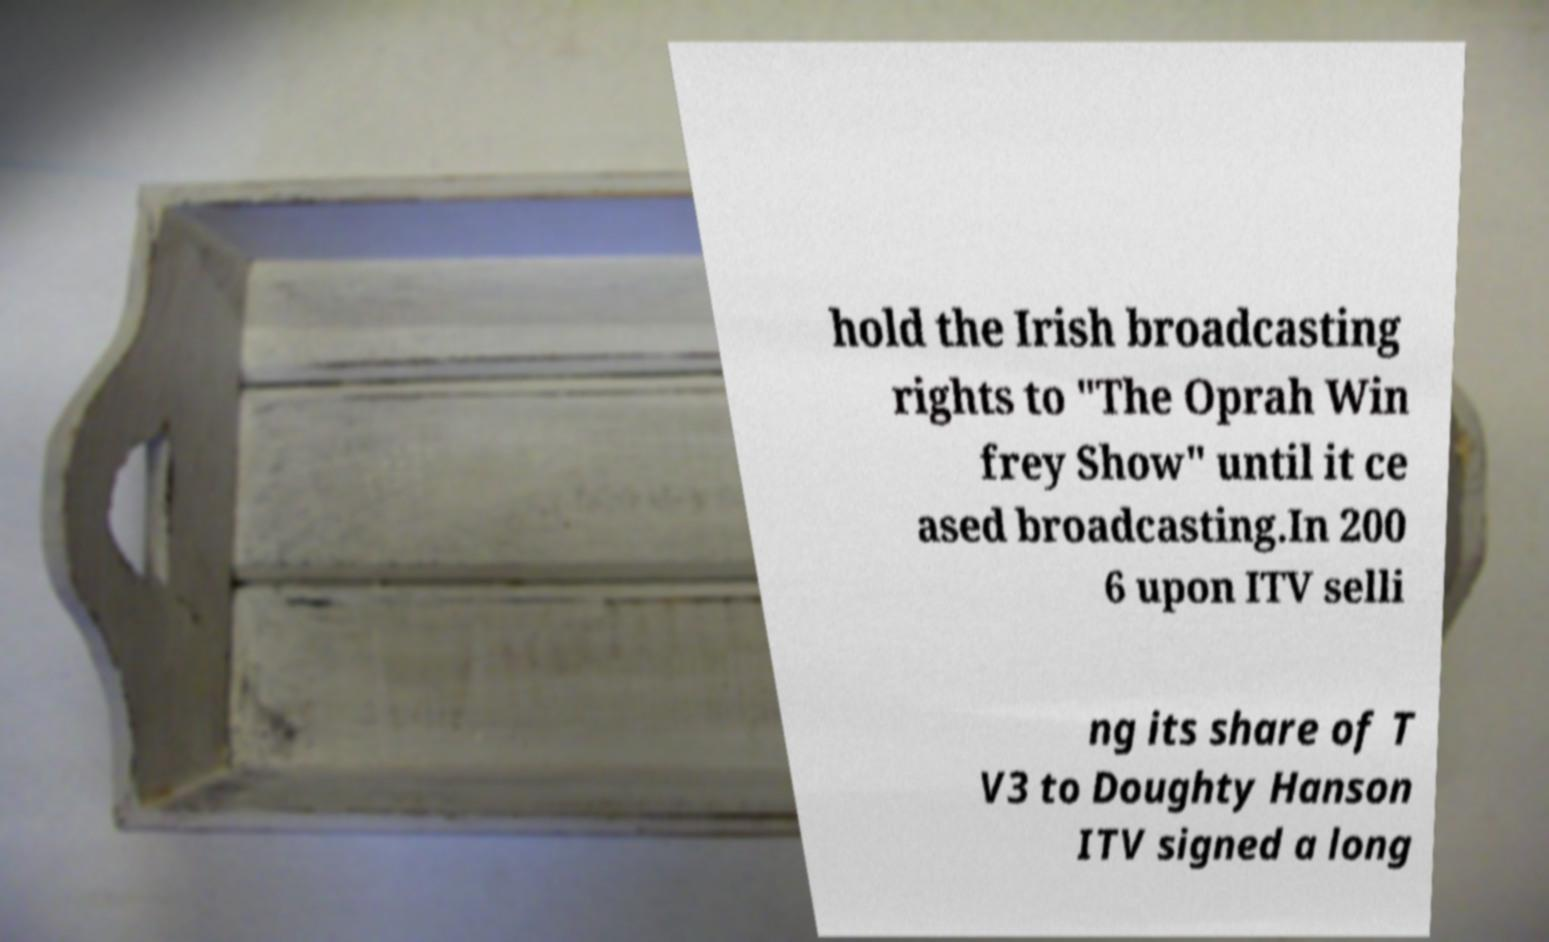Can you read and provide the text displayed in the image?This photo seems to have some interesting text. Can you extract and type it out for me? hold the Irish broadcasting rights to "The Oprah Win frey Show" until it ce ased broadcasting.In 200 6 upon ITV selli ng its share of T V3 to Doughty Hanson ITV signed a long 